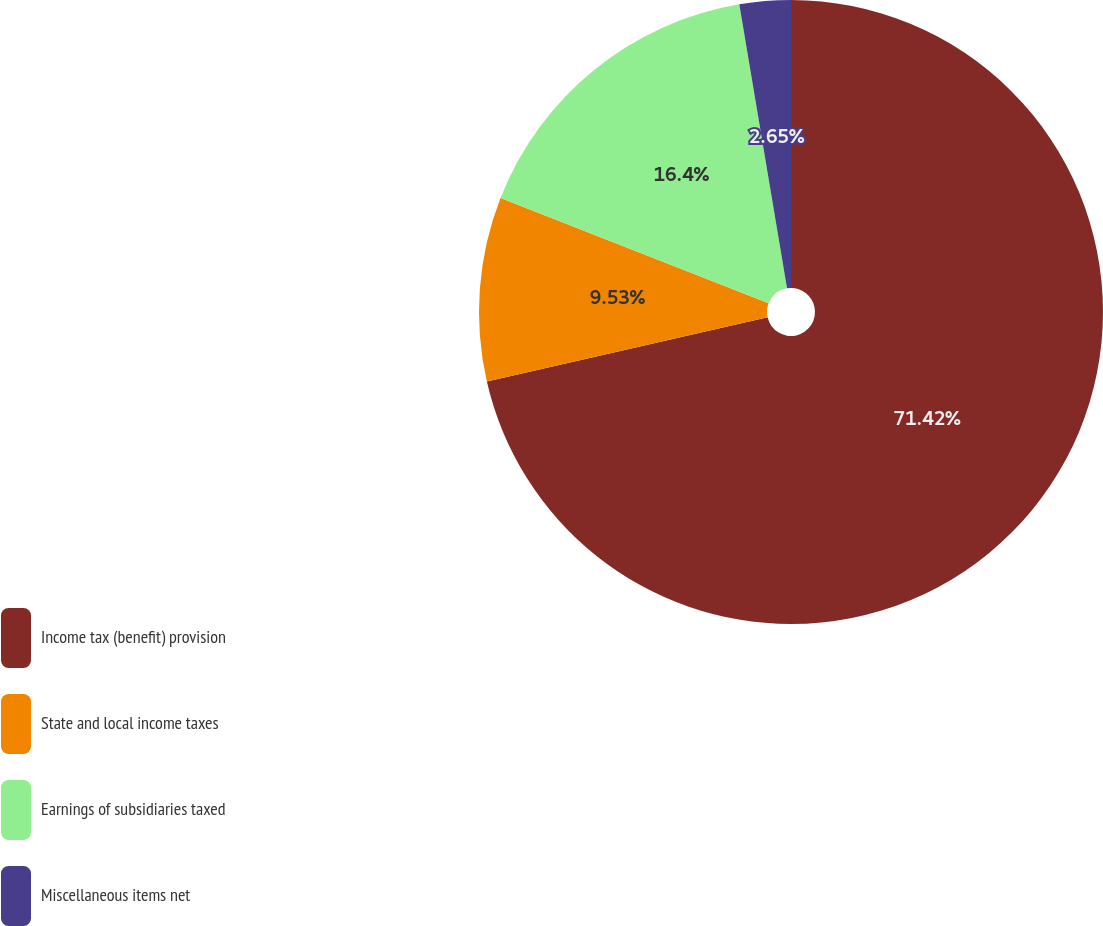<chart> <loc_0><loc_0><loc_500><loc_500><pie_chart><fcel>Income tax (benefit) provision<fcel>State and local income taxes<fcel>Earnings of subsidiaries taxed<fcel>Miscellaneous items net<nl><fcel>71.42%<fcel>9.53%<fcel>16.4%<fcel>2.65%<nl></chart> 